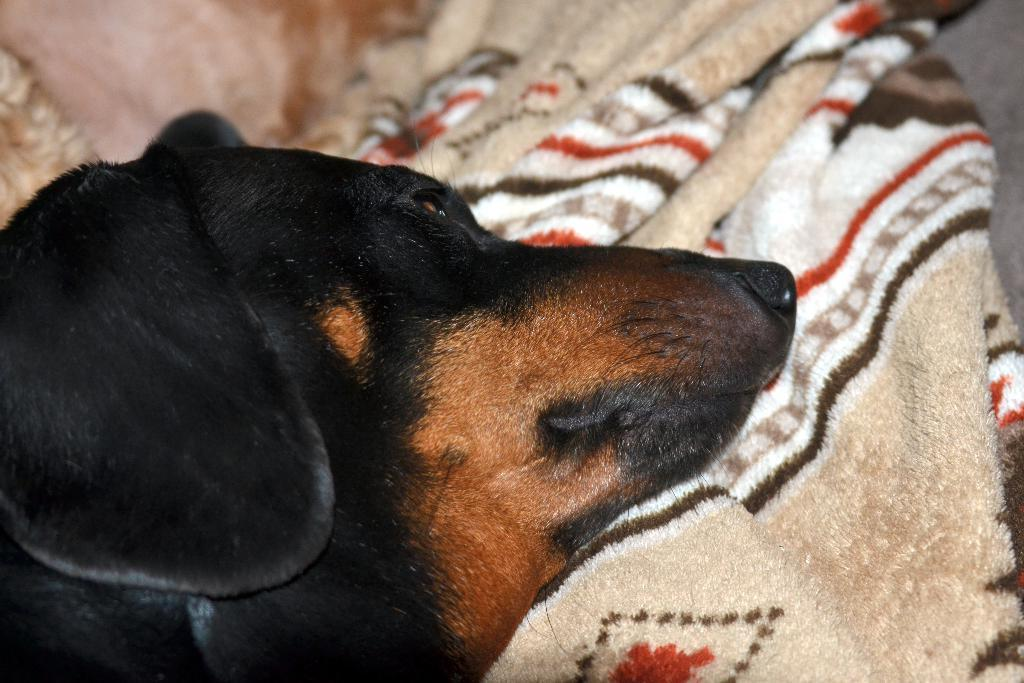What type of animal is in the image? There is a black color dog in the image. What is the dog lying on in the image? There is a blanket in the image. Is the dog making any noise in the image? The provided facts do not mention any noise, so we cannot determine if the dog is making any noise in the image. What type of appliance can be seen in the image? There is no appliance present in the image; it only features a black color dog and a blanket. 